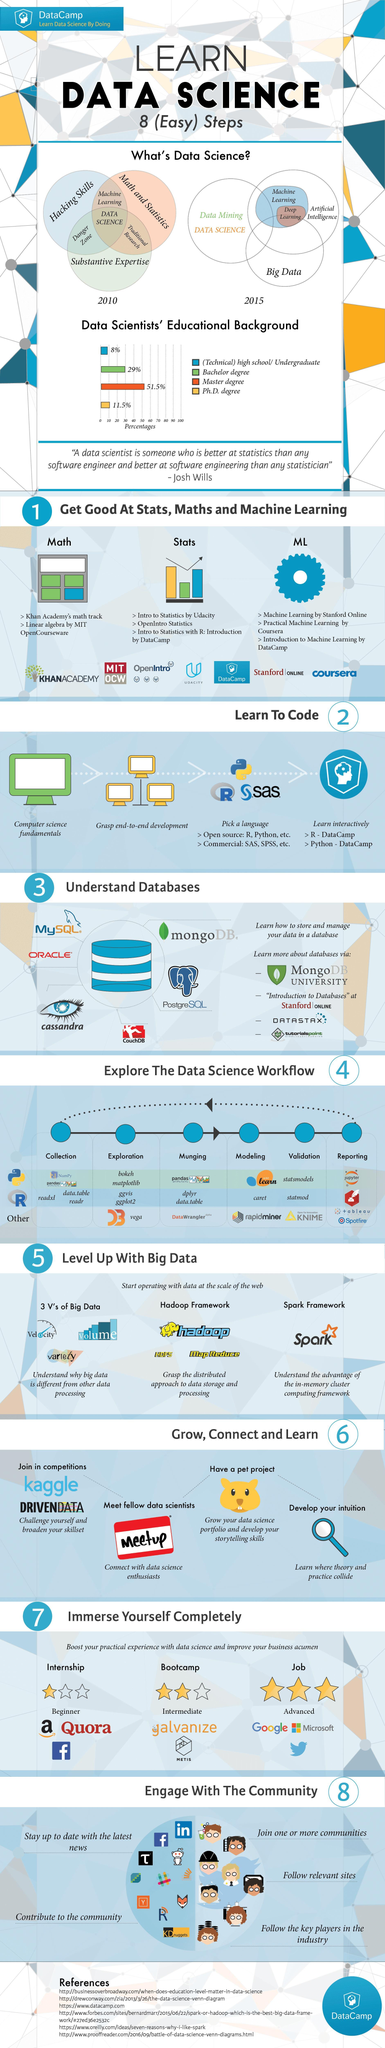Which disciplines are embedded within Artificial Intelligence?
Answer the question with a short phrase. Machine Learning, Deep Learning Which skills are essential for Machine Learning? Hacking, Math and Statistics Which is the highest degree most data scientist have? Master degree How many steps are involved in the Data Science Workflow? 6 Which discipline is the intersection of Math, Statistics, Hacking skills, and Substantive Expertise? Data Science 